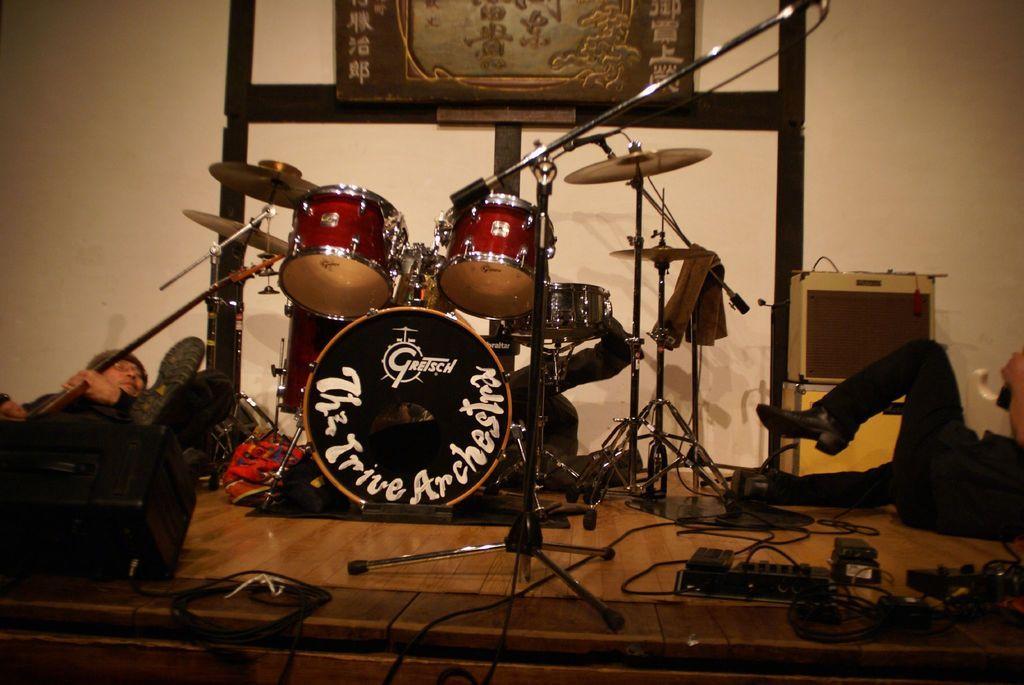Describe this image in one or two sentences. In the picture, there are some people lying on the stage, beside them , in the middle there is a big band, in the background there is a wall. 